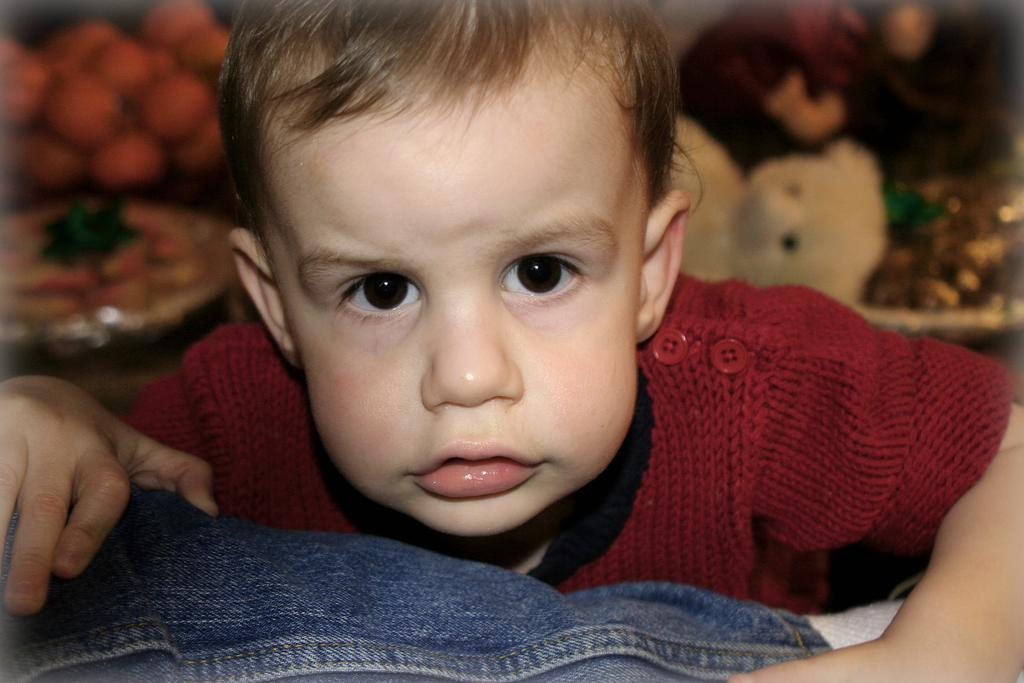Who or what is in the foreground of the image? There is a person in the foreground of the image. What is the person wearing? The person is wearing a red shirt. What can be seen in the background of the image? There are toys, fruits, and other objects in the background of the image. What type of leather material is used to make the van in the image? There is no van present in the image, so it is not possible to determine the type of leather material used. 